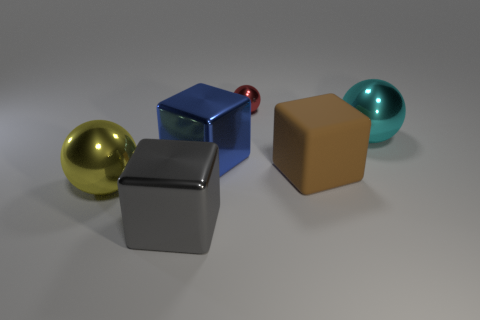Add 1 large shiny balls. How many objects exist? 7 Add 4 large gray shiny blocks. How many large gray shiny blocks exist? 5 Subtract 0 purple cubes. How many objects are left? 6 Subtract all large brown objects. Subtract all blue metal things. How many objects are left? 4 Add 5 large gray metallic objects. How many large gray metallic objects are left? 6 